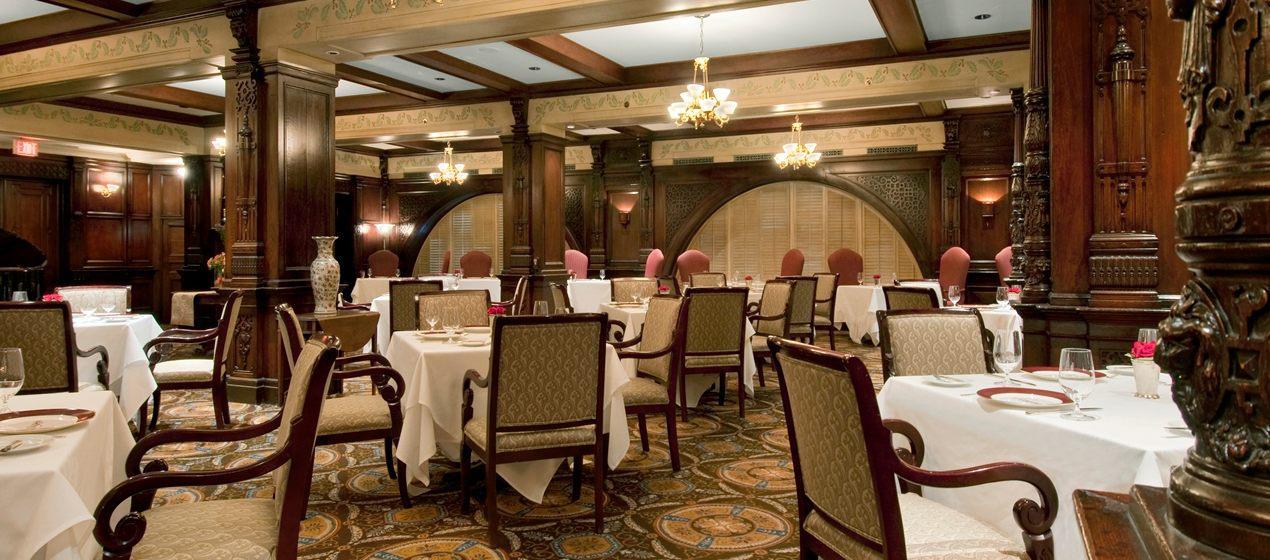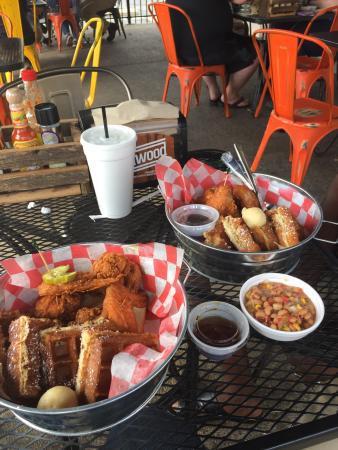The first image is the image on the left, the second image is the image on the right. Assess this claim about the two images: "There ae six dropped lights hanging over the long bar.". Correct or not? Answer yes or no. No. The first image is the image on the left, the second image is the image on the right. Considering the images on both sides, is "The vacant dining tables have lit candles on them." valid? Answer yes or no. No. 